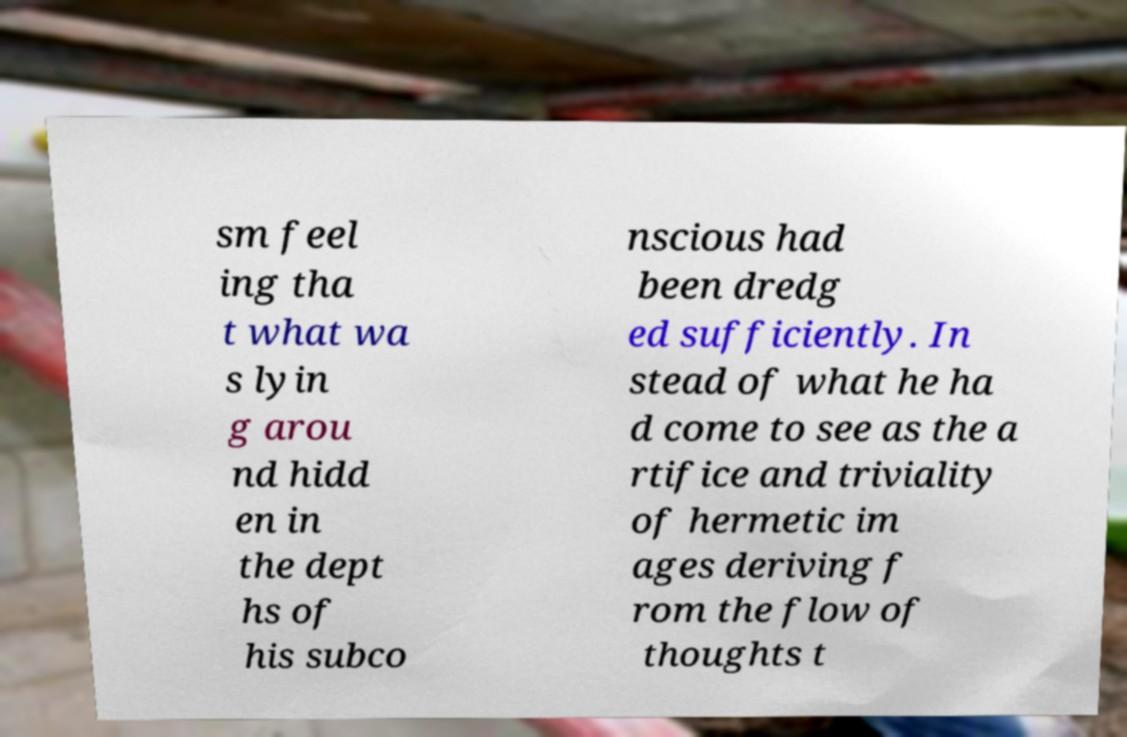Can you read and provide the text displayed in the image?This photo seems to have some interesting text. Can you extract and type it out for me? sm feel ing tha t what wa s lyin g arou nd hidd en in the dept hs of his subco nscious had been dredg ed sufficiently. In stead of what he ha d come to see as the a rtifice and triviality of hermetic im ages deriving f rom the flow of thoughts t 